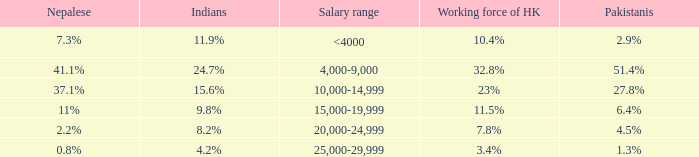If the salary range is 4,000-9,000, what is the Indians %? 24.7%. 